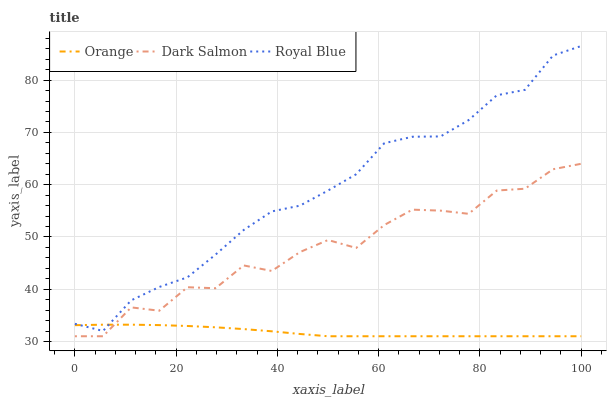Does Orange have the minimum area under the curve?
Answer yes or no. Yes. Does Royal Blue have the maximum area under the curve?
Answer yes or no. Yes. Does Dark Salmon have the minimum area under the curve?
Answer yes or no. No. Does Dark Salmon have the maximum area under the curve?
Answer yes or no. No. Is Orange the smoothest?
Answer yes or no. Yes. Is Dark Salmon the roughest?
Answer yes or no. Yes. Is Royal Blue the smoothest?
Answer yes or no. No. Is Royal Blue the roughest?
Answer yes or no. No. Does Orange have the lowest value?
Answer yes or no. Yes. Does Royal Blue have the lowest value?
Answer yes or no. No. Does Royal Blue have the highest value?
Answer yes or no. Yes. Does Dark Salmon have the highest value?
Answer yes or no. No. Is Dark Salmon less than Royal Blue?
Answer yes or no. Yes. Is Royal Blue greater than Dark Salmon?
Answer yes or no. Yes. Does Royal Blue intersect Orange?
Answer yes or no. Yes. Is Royal Blue less than Orange?
Answer yes or no. No. Is Royal Blue greater than Orange?
Answer yes or no. No. Does Dark Salmon intersect Royal Blue?
Answer yes or no. No. 